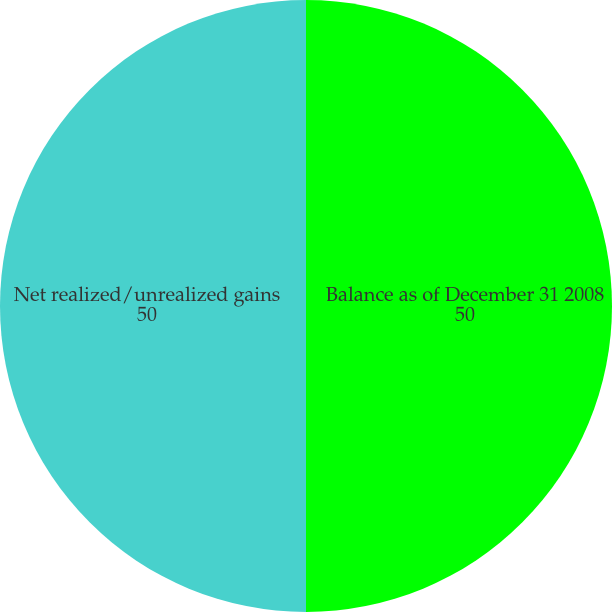Convert chart to OTSL. <chart><loc_0><loc_0><loc_500><loc_500><pie_chart><fcel>Balance as of December 31 2008<fcel>Net realized/unrealized gains<nl><fcel>50.0%<fcel>50.0%<nl></chart> 